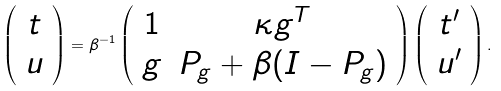Convert formula to latex. <formula><loc_0><loc_0><loc_500><loc_500>\left ( \begin{array} { c } t \\ u \end{array} \right ) = \beta ^ { - 1 } \left ( \begin{array} { c c } 1 & \kappa g ^ { T } \\ g & P _ { g } + \beta ( I - P _ { g } ) \end{array} \right ) \left ( \begin{array} { c } t ^ { \prime } \\ u ^ { \prime } \end{array} \right ) .</formula> 